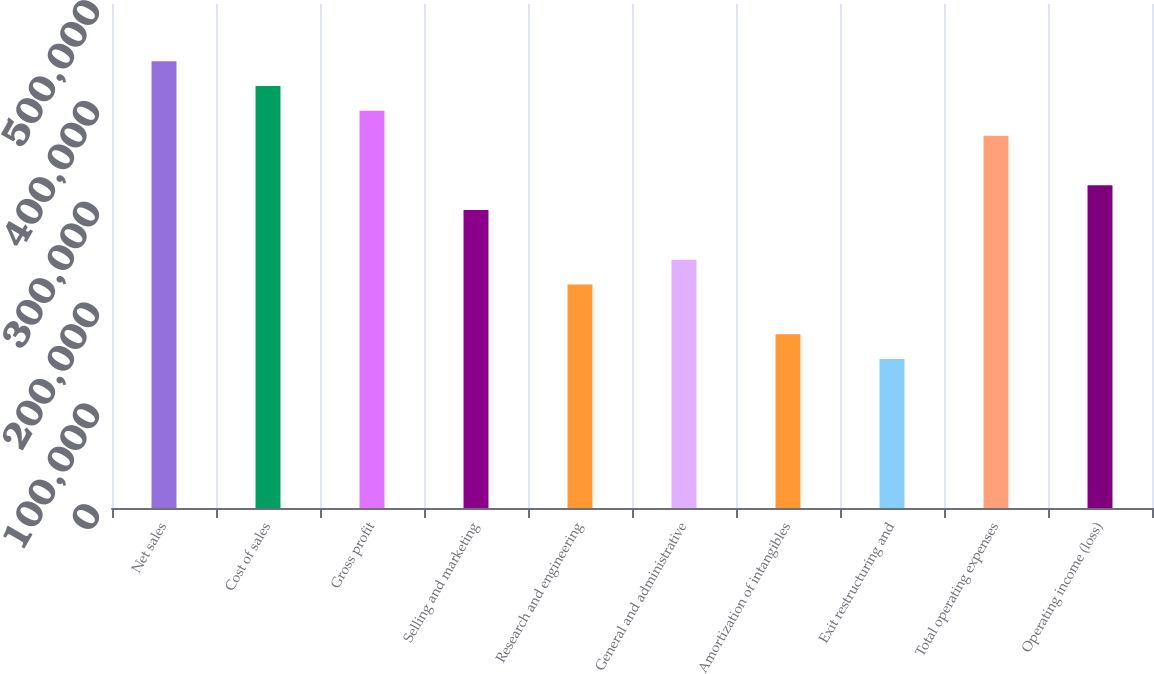<chart> <loc_0><loc_0><loc_500><loc_500><bar_chart><fcel>Net sales<fcel>Cost of sales<fcel>Gross profit<fcel>Selling and marketing<fcel>Research and engineering<fcel>General and administrative<fcel>Amortization of intangibles<fcel>Exit restructuring and<fcel>Total operating expenses<fcel>Operating income (loss)<nl><fcel>443298<fcel>418671<fcel>394043<fcel>295532<fcel>221649<fcel>246277<fcel>172394<fcel>147766<fcel>369415<fcel>320160<nl></chart> 